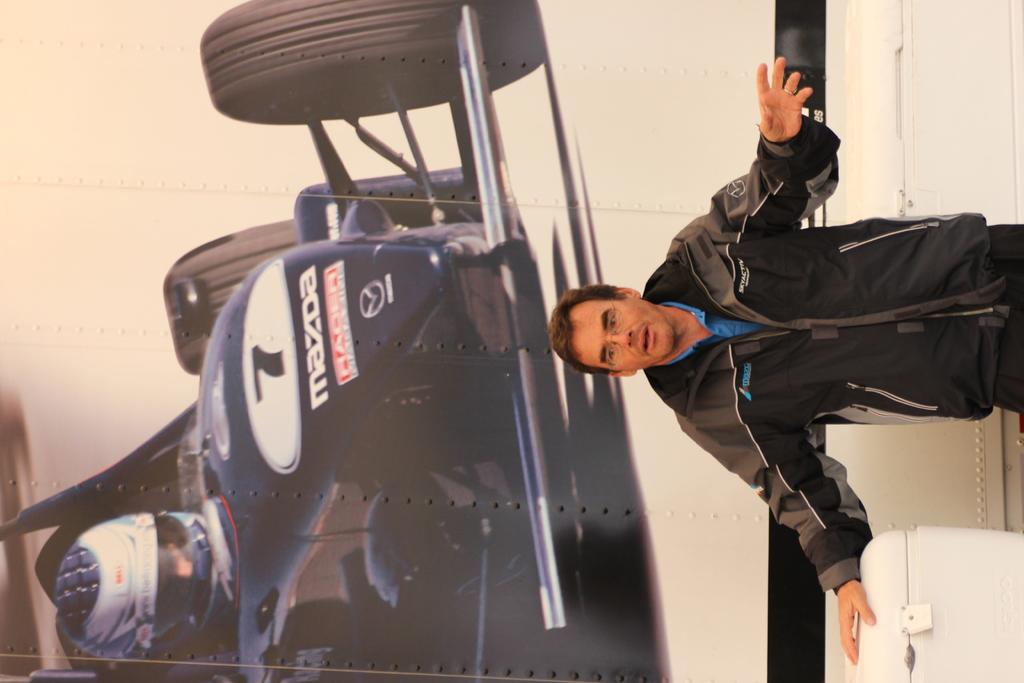What race car manufacturer is shown in the background?
Provide a succinct answer. Mazda. What is the car number?
Your answer should be compact. 7. 